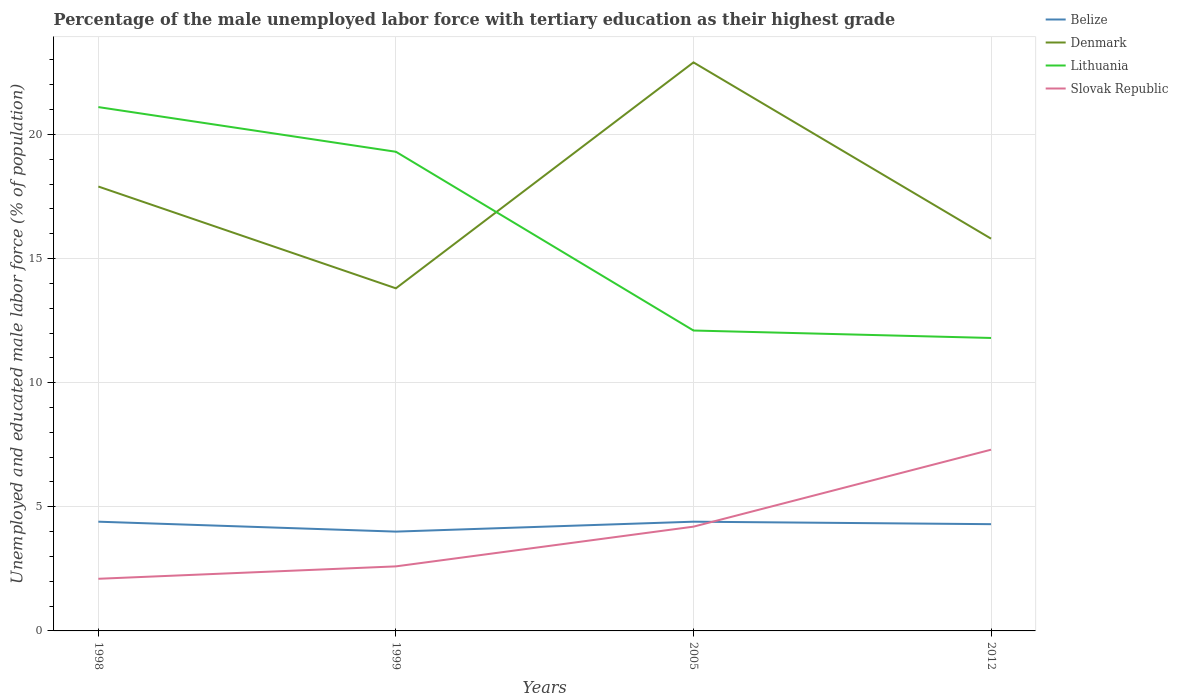How many different coloured lines are there?
Ensure brevity in your answer.  4. Does the line corresponding to Slovak Republic intersect with the line corresponding to Belize?
Make the answer very short. Yes. Across all years, what is the maximum percentage of the unemployed male labor force with tertiary education in Belize?
Keep it short and to the point. 4. What is the total percentage of the unemployed male labor force with tertiary education in Belize in the graph?
Make the answer very short. -0.4. What is the difference between the highest and the second highest percentage of the unemployed male labor force with tertiary education in Belize?
Make the answer very short. 0.4. Is the percentage of the unemployed male labor force with tertiary education in Lithuania strictly greater than the percentage of the unemployed male labor force with tertiary education in Slovak Republic over the years?
Offer a terse response. No. How many lines are there?
Offer a terse response. 4. What is the difference between two consecutive major ticks on the Y-axis?
Make the answer very short. 5. Are the values on the major ticks of Y-axis written in scientific E-notation?
Your answer should be very brief. No. Does the graph contain any zero values?
Provide a succinct answer. No. How are the legend labels stacked?
Provide a short and direct response. Vertical. What is the title of the graph?
Offer a very short reply. Percentage of the male unemployed labor force with tertiary education as their highest grade. Does "Timor-Leste" appear as one of the legend labels in the graph?
Offer a very short reply. No. What is the label or title of the Y-axis?
Make the answer very short. Unemployed and educated male labor force (% of population). What is the Unemployed and educated male labor force (% of population) of Belize in 1998?
Keep it short and to the point. 4.4. What is the Unemployed and educated male labor force (% of population) in Denmark in 1998?
Ensure brevity in your answer.  17.9. What is the Unemployed and educated male labor force (% of population) in Lithuania in 1998?
Offer a very short reply. 21.1. What is the Unemployed and educated male labor force (% of population) in Slovak Republic in 1998?
Ensure brevity in your answer.  2.1. What is the Unemployed and educated male labor force (% of population) of Denmark in 1999?
Your answer should be very brief. 13.8. What is the Unemployed and educated male labor force (% of population) of Lithuania in 1999?
Ensure brevity in your answer.  19.3. What is the Unemployed and educated male labor force (% of population) of Slovak Republic in 1999?
Keep it short and to the point. 2.6. What is the Unemployed and educated male labor force (% of population) of Belize in 2005?
Provide a short and direct response. 4.4. What is the Unemployed and educated male labor force (% of population) in Denmark in 2005?
Your response must be concise. 22.9. What is the Unemployed and educated male labor force (% of population) of Lithuania in 2005?
Give a very brief answer. 12.1. What is the Unemployed and educated male labor force (% of population) of Slovak Republic in 2005?
Keep it short and to the point. 4.2. What is the Unemployed and educated male labor force (% of population) of Belize in 2012?
Give a very brief answer. 4.3. What is the Unemployed and educated male labor force (% of population) in Denmark in 2012?
Provide a short and direct response. 15.8. What is the Unemployed and educated male labor force (% of population) of Lithuania in 2012?
Offer a very short reply. 11.8. What is the Unemployed and educated male labor force (% of population) in Slovak Republic in 2012?
Ensure brevity in your answer.  7.3. Across all years, what is the maximum Unemployed and educated male labor force (% of population) of Belize?
Offer a very short reply. 4.4. Across all years, what is the maximum Unemployed and educated male labor force (% of population) of Denmark?
Provide a succinct answer. 22.9. Across all years, what is the maximum Unemployed and educated male labor force (% of population) of Lithuania?
Your answer should be compact. 21.1. Across all years, what is the maximum Unemployed and educated male labor force (% of population) in Slovak Republic?
Ensure brevity in your answer.  7.3. Across all years, what is the minimum Unemployed and educated male labor force (% of population) of Denmark?
Give a very brief answer. 13.8. Across all years, what is the minimum Unemployed and educated male labor force (% of population) in Lithuania?
Give a very brief answer. 11.8. Across all years, what is the minimum Unemployed and educated male labor force (% of population) in Slovak Republic?
Offer a terse response. 2.1. What is the total Unemployed and educated male labor force (% of population) of Denmark in the graph?
Give a very brief answer. 70.4. What is the total Unemployed and educated male labor force (% of population) of Lithuania in the graph?
Your answer should be compact. 64.3. What is the difference between the Unemployed and educated male labor force (% of population) of Denmark in 1998 and that in 1999?
Offer a terse response. 4.1. What is the difference between the Unemployed and educated male labor force (% of population) of Lithuania in 1998 and that in 2012?
Keep it short and to the point. 9.3. What is the difference between the Unemployed and educated male labor force (% of population) of Slovak Republic in 1998 and that in 2012?
Provide a succinct answer. -5.2. What is the difference between the Unemployed and educated male labor force (% of population) of Belize in 1999 and that in 2005?
Make the answer very short. -0.4. What is the difference between the Unemployed and educated male labor force (% of population) of Lithuania in 1999 and that in 2012?
Your answer should be compact. 7.5. What is the difference between the Unemployed and educated male labor force (% of population) in Slovak Republic in 1999 and that in 2012?
Give a very brief answer. -4.7. What is the difference between the Unemployed and educated male labor force (% of population) in Belize in 1998 and the Unemployed and educated male labor force (% of population) in Lithuania in 1999?
Keep it short and to the point. -14.9. What is the difference between the Unemployed and educated male labor force (% of population) in Denmark in 1998 and the Unemployed and educated male labor force (% of population) in Lithuania in 1999?
Ensure brevity in your answer.  -1.4. What is the difference between the Unemployed and educated male labor force (% of population) of Belize in 1998 and the Unemployed and educated male labor force (% of population) of Denmark in 2005?
Offer a very short reply. -18.5. What is the difference between the Unemployed and educated male labor force (% of population) in Belize in 1998 and the Unemployed and educated male labor force (% of population) in Slovak Republic in 2005?
Your response must be concise. 0.2. What is the difference between the Unemployed and educated male labor force (% of population) in Denmark in 1998 and the Unemployed and educated male labor force (% of population) in Lithuania in 2005?
Ensure brevity in your answer.  5.8. What is the difference between the Unemployed and educated male labor force (% of population) in Denmark in 1998 and the Unemployed and educated male labor force (% of population) in Slovak Republic in 2005?
Your response must be concise. 13.7. What is the difference between the Unemployed and educated male labor force (% of population) of Lithuania in 1998 and the Unemployed and educated male labor force (% of population) of Slovak Republic in 2005?
Offer a terse response. 16.9. What is the difference between the Unemployed and educated male labor force (% of population) of Belize in 1998 and the Unemployed and educated male labor force (% of population) of Denmark in 2012?
Make the answer very short. -11.4. What is the difference between the Unemployed and educated male labor force (% of population) of Belize in 1998 and the Unemployed and educated male labor force (% of population) of Lithuania in 2012?
Provide a short and direct response. -7.4. What is the difference between the Unemployed and educated male labor force (% of population) of Belize in 1998 and the Unemployed and educated male labor force (% of population) of Slovak Republic in 2012?
Offer a very short reply. -2.9. What is the difference between the Unemployed and educated male labor force (% of population) of Lithuania in 1998 and the Unemployed and educated male labor force (% of population) of Slovak Republic in 2012?
Give a very brief answer. 13.8. What is the difference between the Unemployed and educated male labor force (% of population) of Belize in 1999 and the Unemployed and educated male labor force (% of population) of Denmark in 2005?
Provide a short and direct response. -18.9. What is the difference between the Unemployed and educated male labor force (% of population) in Belize in 1999 and the Unemployed and educated male labor force (% of population) in Lithuania in 2005?
Your response must be concise. -8.1. What is the difference between the Unemployed and educated male labor force (% of population) of Belize in 1999 and the Unemployed and educated male labor force (% of population) of Slovak Republic in 2005?
Provide a succinct answer. -0.2. What is the difference between the Unemployed and educated male labor force (% of population) of Lithuania in 1999 and the Unemployed and educated male labor force (% of population) of Slovak Republic in 2005?
Your answer should be very brief. 15.1. What is the difference between the Unemployed and educated male labor force (% of population) in Belize in 1999 and the Unemployed and educated male labor force (% of population) in Lithuania in 2012?
Your response must be concise. -7.8. What is the difference between the Unemployed and educated male labor force (% of population) of Denmark in 1999 and the Unemployed and educated male labor force (% of population) of Slovak Republic in 2012?
Offer a very short reply. 6.5. What is the difference between the Unemployed and educated male labor force (% of population) in Belize in 2005 and the Unemployed and educated male labor force (% of population) in Denmark in 2012?
Offer a very short reply. -11.4. What is the difference between the Unemployed and educated male labor force (% of population) in Belize in 2005 and the Unemployed and educated male labor force (% of population) in Lithuania in 2012?
Make the answer very short. -7.4. What is the difference between the Unemployed and educated male labor force (% of population) in Denmark in 2005 and the Unemployed and educated male labor force (% of population) in Slovak Republic in 2012?
Ensure brevity in your answer.  15.6. What is the average Unemployed and educated male labor force (% of population) in Belize per year?
Provide a short and direct response. 4.28. What is the average Unemployed and educated male labor force (% of population) of Lithuania per year?
Provide a short and direct response. 16.07. What is the average Unemployed and educated male labor force (% of population) of Slovak Republic per year?
Provide a short and direct response. 4.05. In the year 1998, what is the difference between the Unemployed and educated male labor force (% of population) in Belize and Unemployed and educated male labor force (% of population) in Denmark?
Provide a succinct answer. -13.5. In the year 1998, what is the difference between the Unemployed and educated male labor force (% of population) in Belize and Unemployed and educated male labor force (% of population) in Lithuania?
Provide a succinct answer. -16.7. In the year 1998, what is the difference between the Unemployed and educated male labor force (% of population) in Belize and Unemployed and educated male labor force (% of population) in Slovak Republic?
Keep it short and to the point. 2.3. In the year 1998, what is the difference between the Unemployed and educated male labor force (% of population) of Denmark and Unemployed and educated male labor force (% of population) of Slovak Republic?
Offer a terse response. 15.8. In the year 1999, what is the difference between the Unemployed and educated male labor force (% of population) in Belize and Unemployed and educated male labor force (% of population) in Lithuania?
Ensure brevity in your answer.  -15.3. In the year 1999, what is the difference between the Unemployed and educated male labor force (% of population) in Belize and Unemployed and educated male labor force (% of population) in Slovak Republic?
Offer a terse response. 1.4. In the year 1999, what is the difference between the Unemployed and educated male labor force (% of population) of Denmark and Unemployed and educated male labor force (% of population) of Slovak Republic?
Your answer should be very brief. 11.2. In the year 1999, what is the difference between the Unemployed and educated male labor force (% of population) of Lithuania and Unemployed and educated male labor force (% of population) of Slovak Republic?
Your answer should be very brief. 16.7. In the year 2005, what is the difference between the Unemployed and educated male labor force (% of population) in Belize and Unemployed and educated male labor force (% of population) in Denmark?
Give a very brief answer. -18.5. In the year 2005, what is the difference between the Unemployed and educated male labor force (% of population) in Belize and Unemployed and educated male labor force (% of population) in Lithuania?
Make the answer very short. -7.7. In the year 2005, what is the difference between the Unemployed and educated male labor force (% of population) of Denmark and Unemployed and educated male labor force (% of population) of Lithuania?
Give a very brief answer. 10.8. In the year 2005, what is the difference between the Unemployed and educated male labor force (% of population) in Denmark and Unemployed and educated male labor force (% of population) in Slovak Republic?
Provide a short and direct response. 18.7. In the year 2005, what is the difference between the Unemployed and educated male labor force (% of population) of Lithuania and Unemployed and educated male labor force (% of population) of Slovak Republic?
Your answer should be compact. 7.9. In the year 2012, what is the difference between the Unemployed and educated male labor force (% of population) of Belize and Unemployed and educated male labor force (% of population) of Lithuania?
Keep it short and to the point. -7.5. In the year 2012, what is the difference between the Unemployed and educated male labor force (% of population) in Denmark and Unemployed and educated male labor force (% of population) in Lithuania?
Offer a terse response. 4. In the year 2012, what is the difference between the Unemployed and educated male labor force (% of population) in Lithuania and Unemployed and educated male labor force (% of population) in Slovak Republic?
Your answer should be compact. 4.5. What is the ratio of the Unemployed and educated male labor force (% of population) of Belize in 1998 to that in 1999?
Keep it short and to the point. 1.1. What is the ratio of the Unemployed and educated male labor force (% of population) in Denmark in 1998 to that in 1999?
Provide a succinct answer. 1.3. What is the ratio of the Unemployed and educated male labor force (% of population) of Lithuania in 1998 to that in 1999?
Provide a short and direct response. 1.09. What is the ratio of the Unemployed and educated male labor force (% of population) in Slovak Republic in 1998 to that in 1999?
Your response must be concise. 0.81. What is the ratio of the Unemployed and educated male labor force (% of population) of Denmark in 1998 to that in 2005?
Offer a very short reply. 0.78. What is the ratio of the Unemployed and educated male labor force (% of population) of Lithuania in 1998 to that in 2005?
Your answer should be very brief. 1.74. What is the ratio of the Unemployed and educated male labor force (% of population) of Belize in 1998 to that in 2012?
Provide a succinct answer. 1.02. What is the ratio of the Unemployed and educated male labor force (% of population) in Denmark in 1998 to that in 2012?
Make the answer very short. 1.13. What is the ratio of the Unemployed and educated male labor force (% of population) of Lithuania in 1998 to that in 2012?
Your answer should be compact. 1.79. What is the ratio of the Unemployed and educated male labor force (% of population) of Slovak Republic in 1998 to that in 2012?
Make the answer very short. 0.29. What is the ratio of the Unemployed and educated male labor force (% of population) of Denmark in 1999 to that in 2005?
Your answer should be very brief. 0.6. What is the ratio of the Unemployed and educated male labor force (% of population) of Lithuania in 1999 to that in 2005?
Give a very brief answer. 1.59. What is the ratio of the Unemployed and educated male labor force (% of population) in Slovak Republic in 1999 to that in 2005?
Offer a very short reply. 0.62. What is the ratio of the Unemployed and educated male labor force (% of population) in Belize in 1999 to that in 2012?
Provide a succinct answer. 0.93. What is the ratio of the Unemployed and educated male labor force (% of population) of Denmark in 1999 to that in 2012?
Offer a terse response. 0.87. What is the ratio of the Unemployed and educated male labor force (% of population) in Lithuania in 1999 to that in 2012?
Provide a short and direct response. 1.64. What is the ratio of the Unemployed and educated male labor force (% of population) in Slovak Republic in 1999 to that in 2012?
Ensure brevity in your answer.  0.36. What is the ratio of the Unemployed and educated male labor force (% of population) of Belize in 2005 to that in 2012?
Offer a very short reply. 1.02. What is the ratio of the Unemployed and educated male labor force (% of population) of Denmark in 2005 to that in 2012?
Your response must be concise. 1.45. What is the ratio of the Unemployed and educated male labor force (% of population) in Lithuania in 2005 to that in 2012?
Offer a terse response. 1.03. What is the ratio of the Unemployed and educated male labor force (% of population) of Slovak Republic in 2005 to that in 2012?
Your answer should be very brief. 0.58. What is the difference between the highest and the second highest Unemployed and educated male labor force (% of population) in Belize?
Make the answer very short. 0. What is the difference between the highest and the lowest Unemployed and educated male labor force (% of population) in Lithuania?
Your answer should be compact. 9.3. What is the difference between the highest and the lowest Unemployed and educated male labor force (% of population) of Slovak Republic?
Provide a succinct answer. 5.2. 